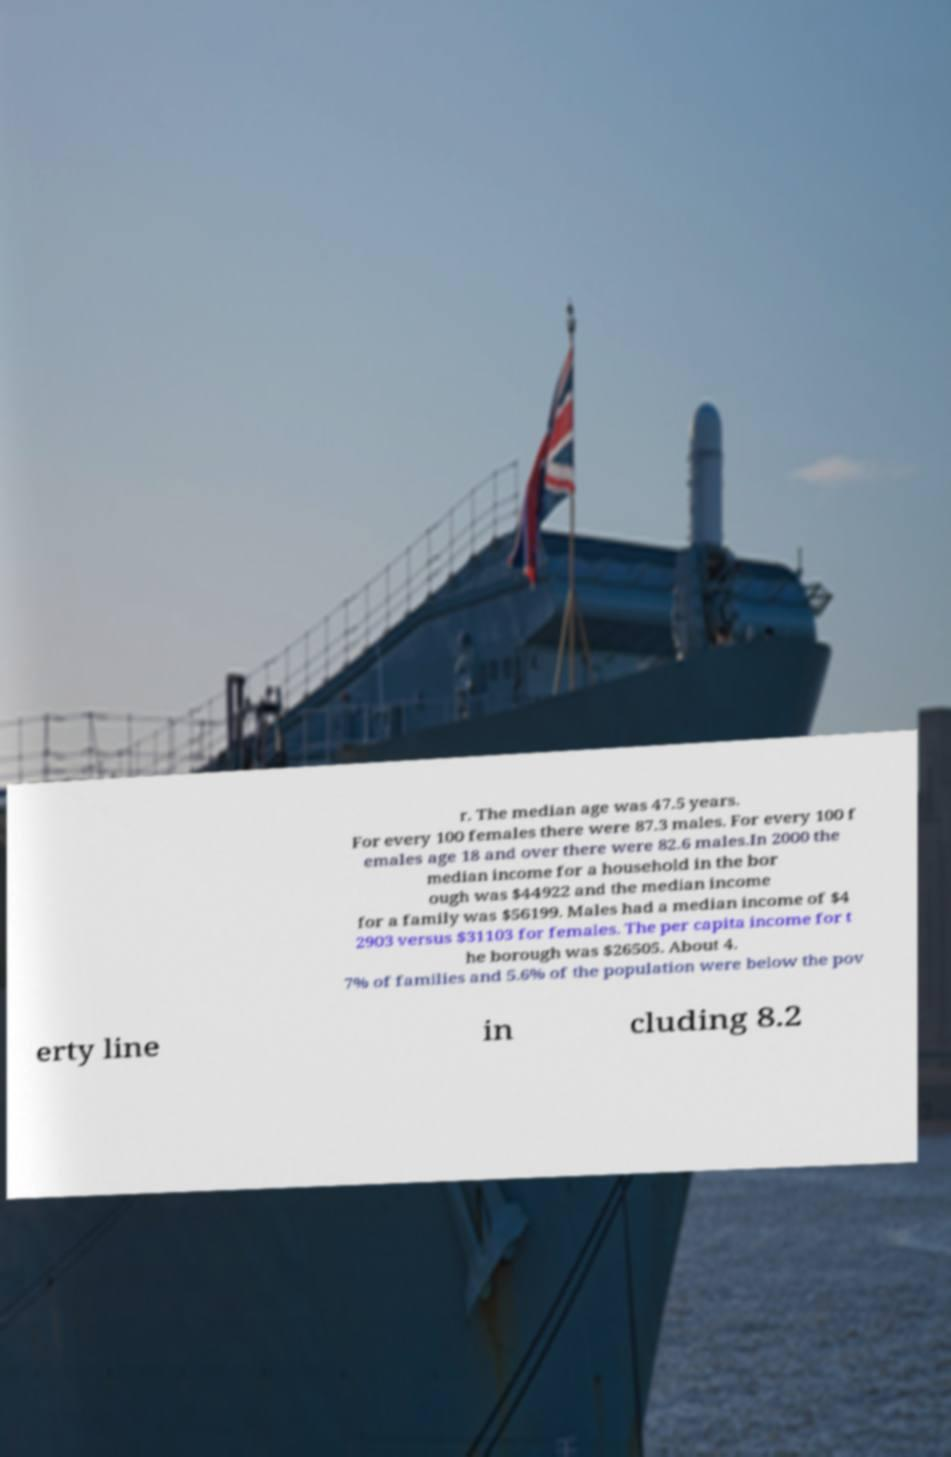Please read and relay the text visible in this image. What does it say? r. The median age was 47.5 years. For every 100 females there were 87.3 males. For every 100 f emales age 18 and over there were 82.6 males.In 2000 the median income for a household in the bor ough was $44922 and the median income for a family was $56199. Males had a median income of $4 2903 versus $31103 for females. The per capita income for t he borough was $26505. About 4. 7% of families and 5.6% of the population were below the pov erty line in cluding 8.2 